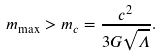Convert formula to latex. <formula><loc_0><loc_0><loc_500><loc_500>m _ { \max } > m _ { c } = \frac { c ^ { 2 } } { 3 G \sqrt { \Lambda } } .</formula> 